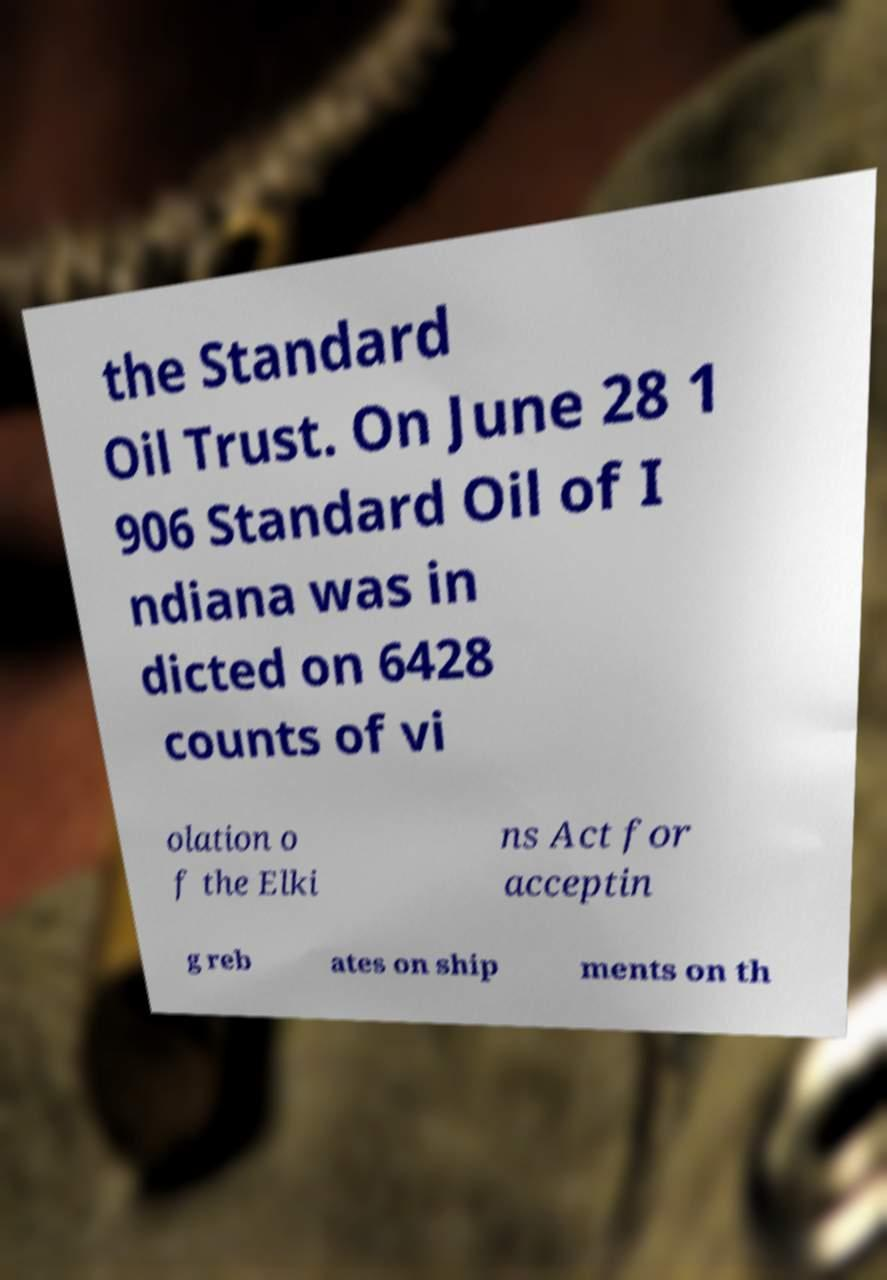There's text embedded in this image that I need extracted. Can you transcribe it verbatim? the Standard Oil Trust. On June 28 1 906 Standard Oil of I ndiana was in dicted on 6428 counts of vi olation o f the Elki ns Act for acceptin g reb ates on ship ments on th 